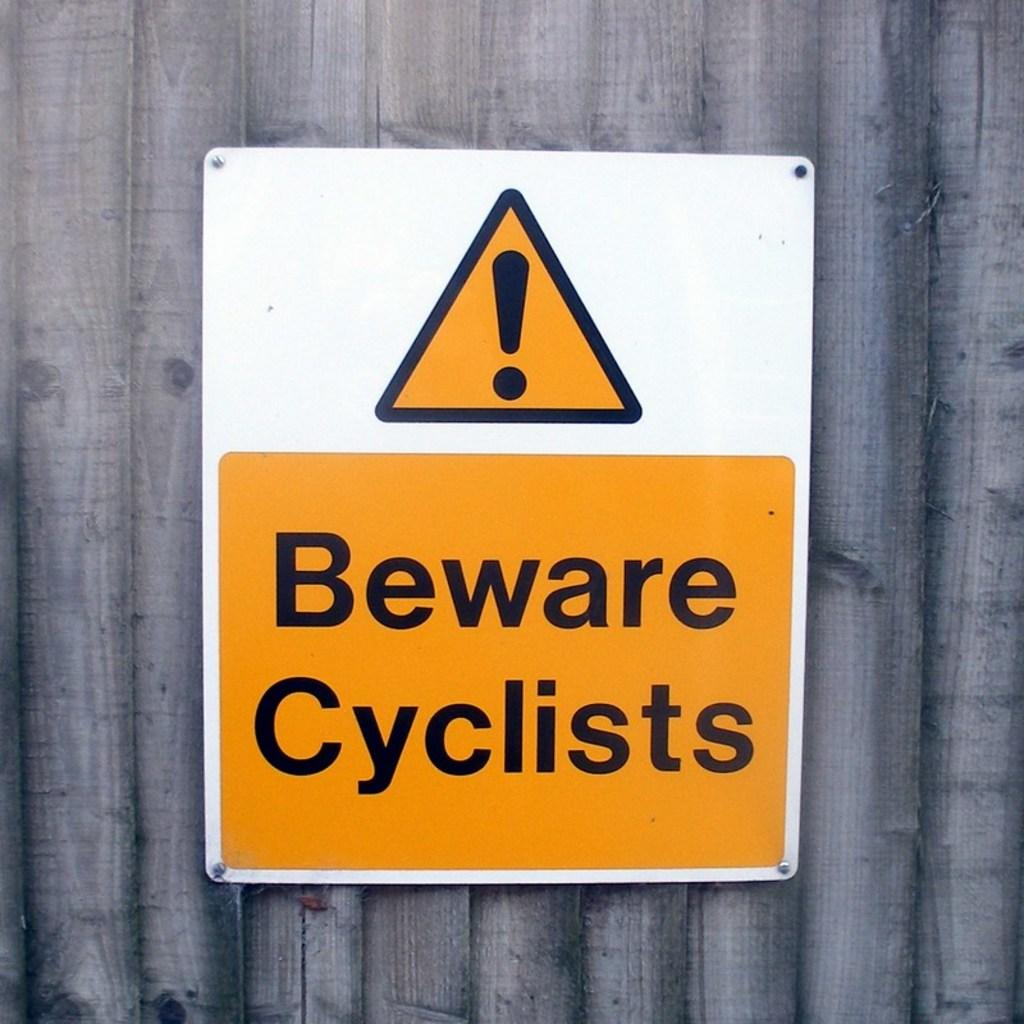<image>
Provide a brief description of the given image. A yellow and white sign with the words Beware Cyclists on it. 